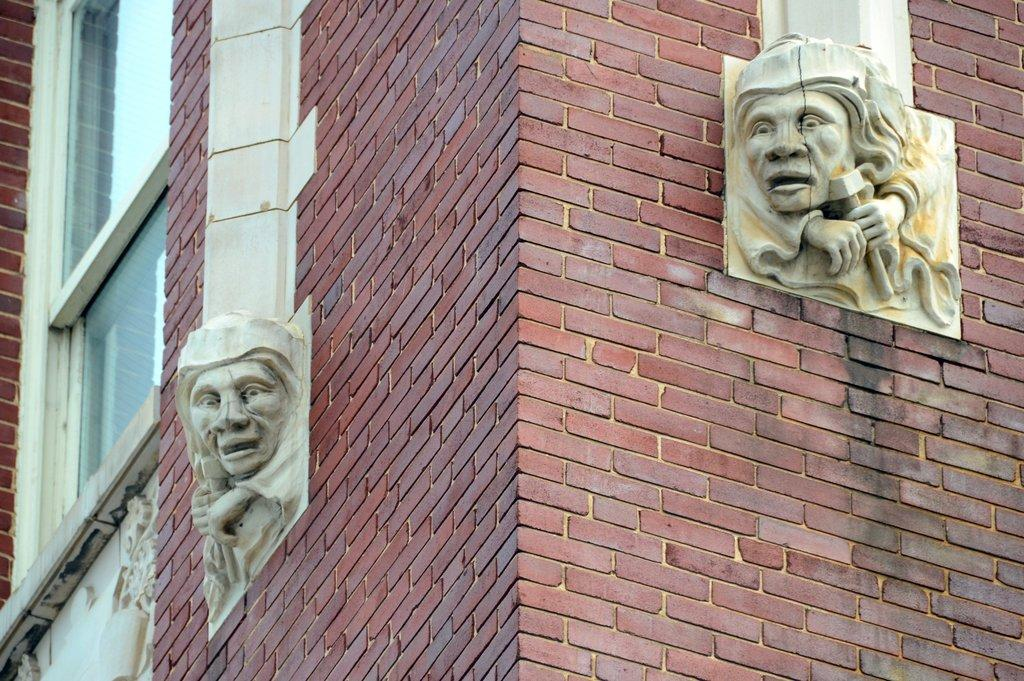What type of objects can be seen in the image? There are statues in the image. What architectural features are present in the image? There are walls in the image. Is there any opening in the walls visible in the image? Yes, there is a window in the image. Can you see any streams or knots in the image? No, there are no streams or knots present in the image. 